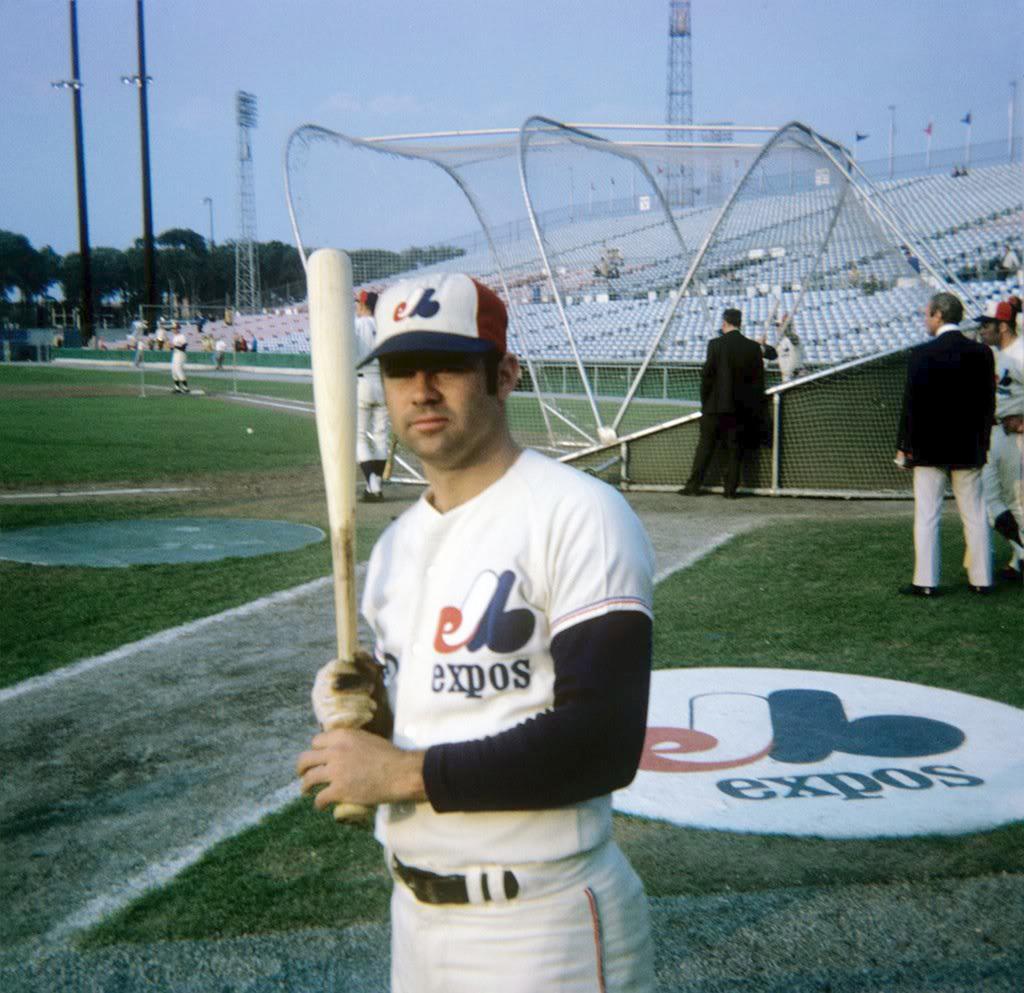What color are the letters on the jersey?
Offer a very short reply. Answering does not require reading text in the image. 